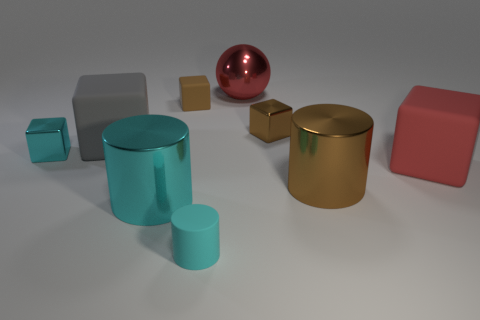Can you describe the shapes and colors of the objects seen in the image? Certainly! This image showcases geometric diversity, featuring cylindrical, cuboid, and spherical shapes. The colors range from a turquoise and gold with metallic sheen to more subdued tones of gray and rose, composing a striking and harmonious visual assortment. Which object seems to stand out the most, and why do you think so? The spherical object, boasting a reflective red surface, immediately draws the eye, likely due to its vivid color that contrasts with the muted tones of the other objects and its unique, unobstructed shape that distinguishes it from the other geometric forms. 